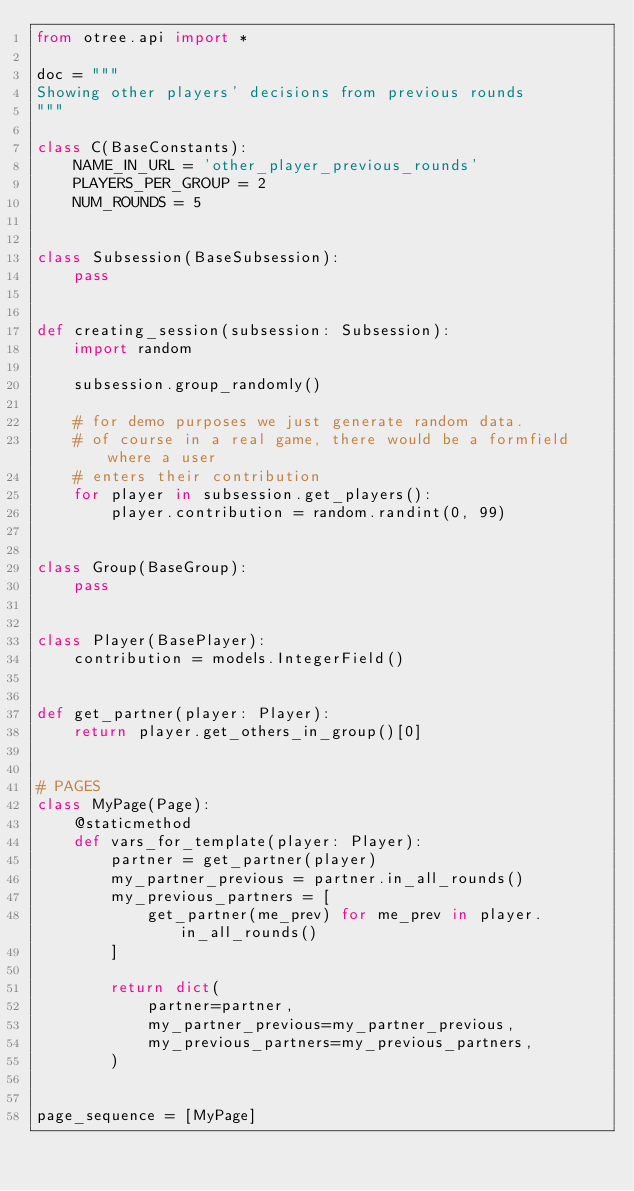<code> <loc_0><loc_0><loc_500><loc_500><_Python_>from otree.api import *

doc = """
Showing other players' decisions from previous rounds
"""

class C(BaseConstants):
    NAME_IN_URL = 'other_player_previous_rounds'
    PLAYERS_PER_GROUP = 2
    NUM_ROUNDS = 5


class Subsession(BaseSubsession):
    pass


def creating_session(subsession: Subsession):
    import random

    subsession.group_randomly()

    # for demo purposes we just generate random data.
    # of course in a real game, there would be a formfield where a user
    # enters their contribution
    for player in subsession.get_players():
        player.contribution = random.randint(0, 99)


class Group(BaseGroup):
    pass


class Player(BasePlayer):
    contribution = models.IntegerField()


def get_partner(player: Player):
    return player.get_others_in_group()[0]


# PAGES
class MyPage(Page):
    @staticmethod
    def vars_for_template(player: Player):
        partner = get_partner(player)
        my_partner_previous = partner.in_all_rounds()
        my_previous_partners = [
            get_partner(me_prev) for me_prev in player.in_all_rounds()
        ]

        return dict(
            partner=partner,
            my_partner_previous=my_partner_previous,
            my_previous_partners=my_previous_partners,
        )


page_sequence = [MyPage]
</code> 